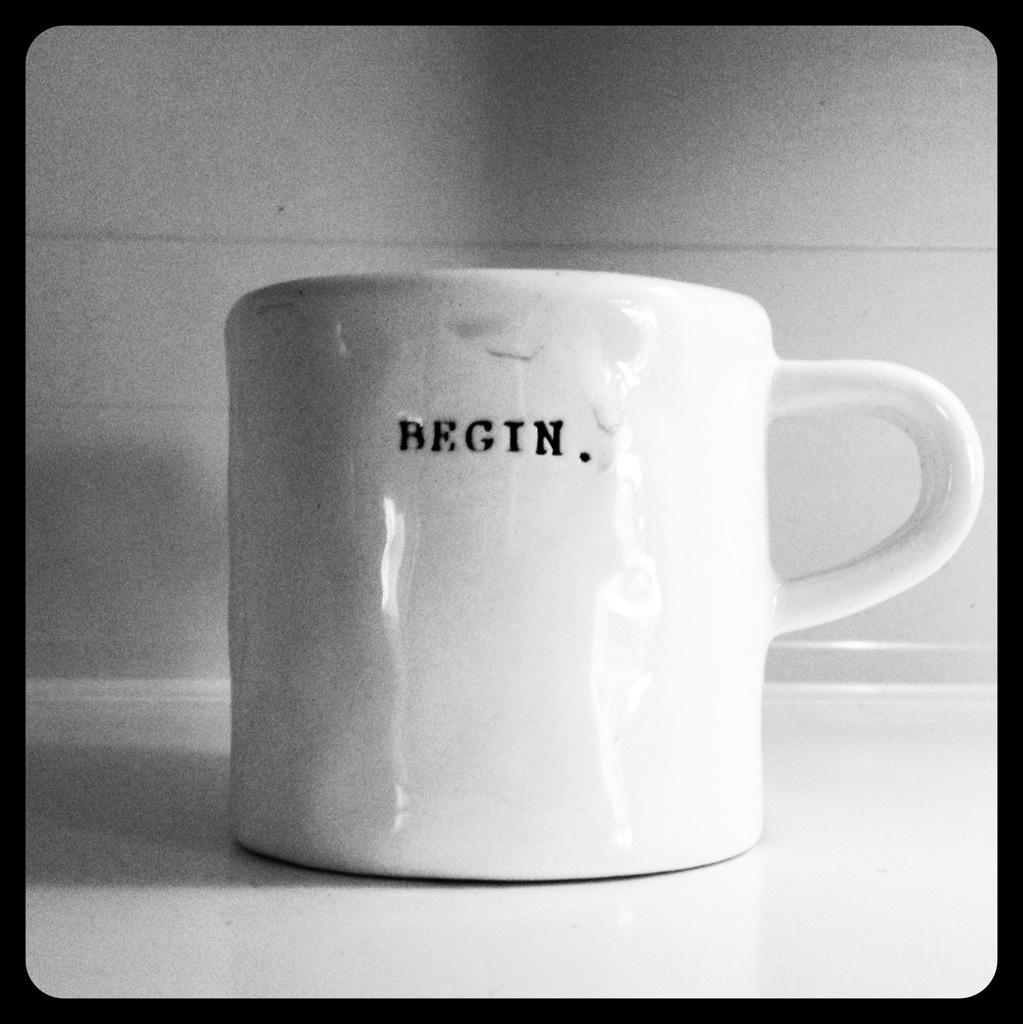<image>
Write a terse but informative summary of the picture. A white mug with the word begin printed in black. 